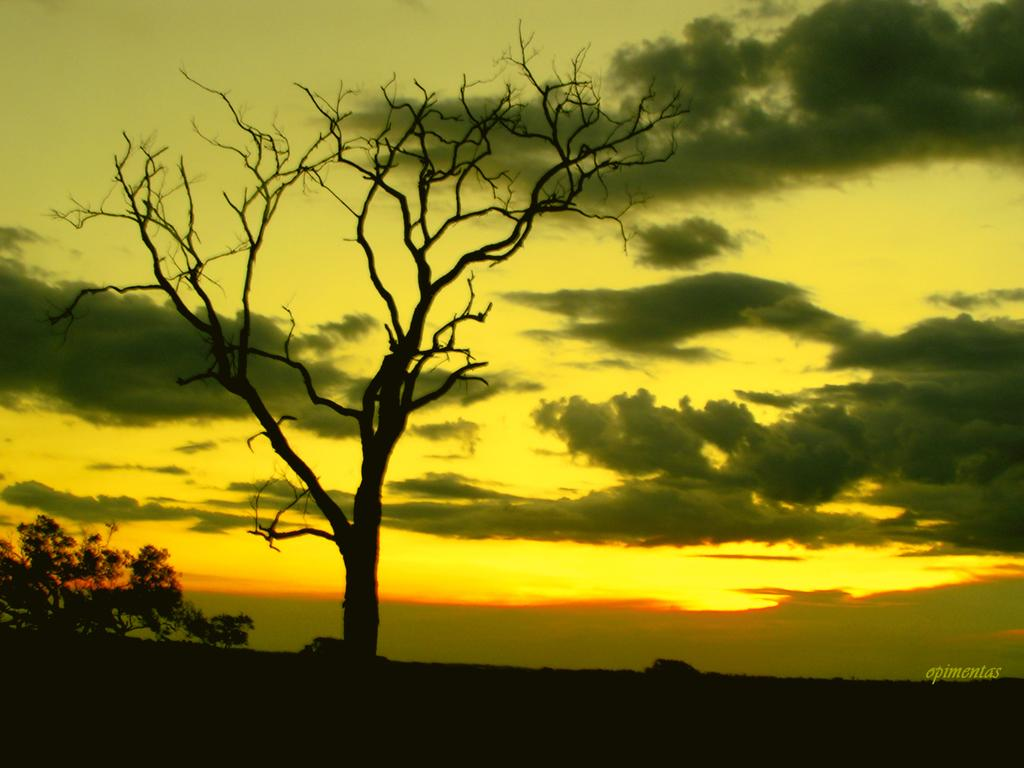What type of tree is in the image? There is a dry tree in the image. What can be seen in the background of the image? The sky is visible in the image. What is the condition of the sky in the image? Clouds are present in the sky. How many dimes are scattered around the base of the tree in the image? There are no dimes present in the image; it only features a dry tree and the sky with clouds. 